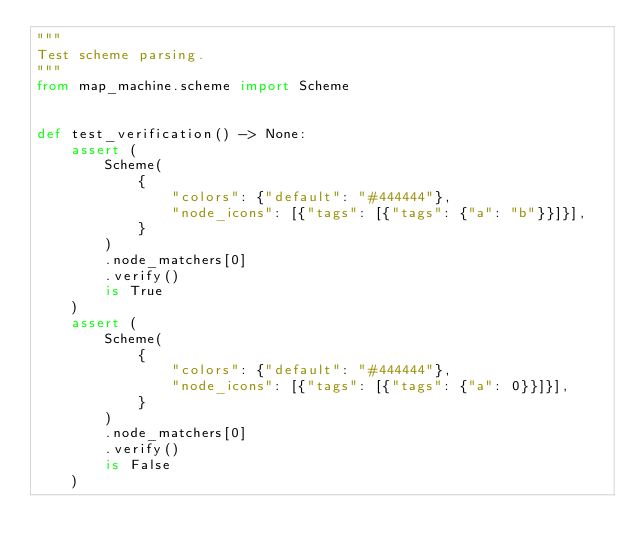Convert code to text. <code><loc_0><loc_0><loc_500><loc_500><_Python_>"""
Test scheme parsing.
"""
from map_machine.scheme import Scheme


def test_verification() -> None:
    assert (
        Scheme(
            {
                "colors": {"default": "#444444"},
                "node_icons": [{"tags": [{"tags": {"a": "b"}}]}],
            }
        )
        .node_matchers[0]
        .verify()
        is True
    )
    assert (
        Scheme(
            {
                "colors": {"default": "#444444"},
                "node_icons": [{"tags": [{"tags": {"a": 0}}]}],
            }
        )
        .node_matchers[0]
        .verify()
        is False
    )
</code> 